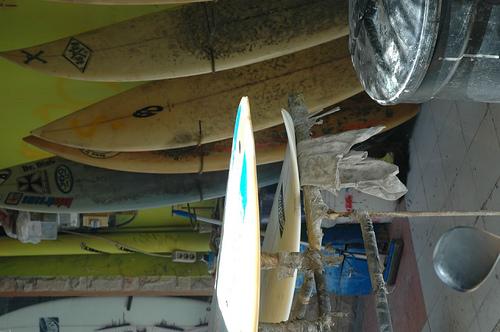Is the photo sideways?
Concise answer only. Yes. Are surfboards being stored here?
Give a very brief answer. Yes. What color are the three surfboards closest to the top of the picture?
Quick response, please. Yellow. 